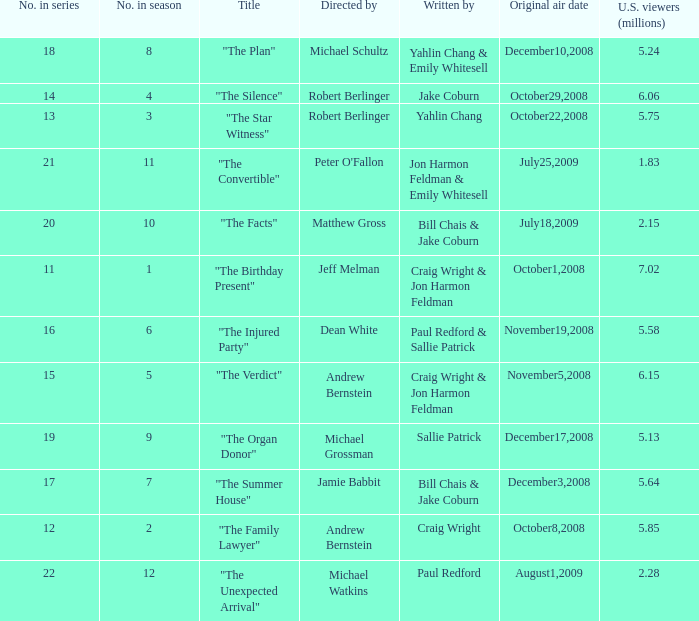What is the debut air date of the episode directed by jeff melman? October1,2008. 